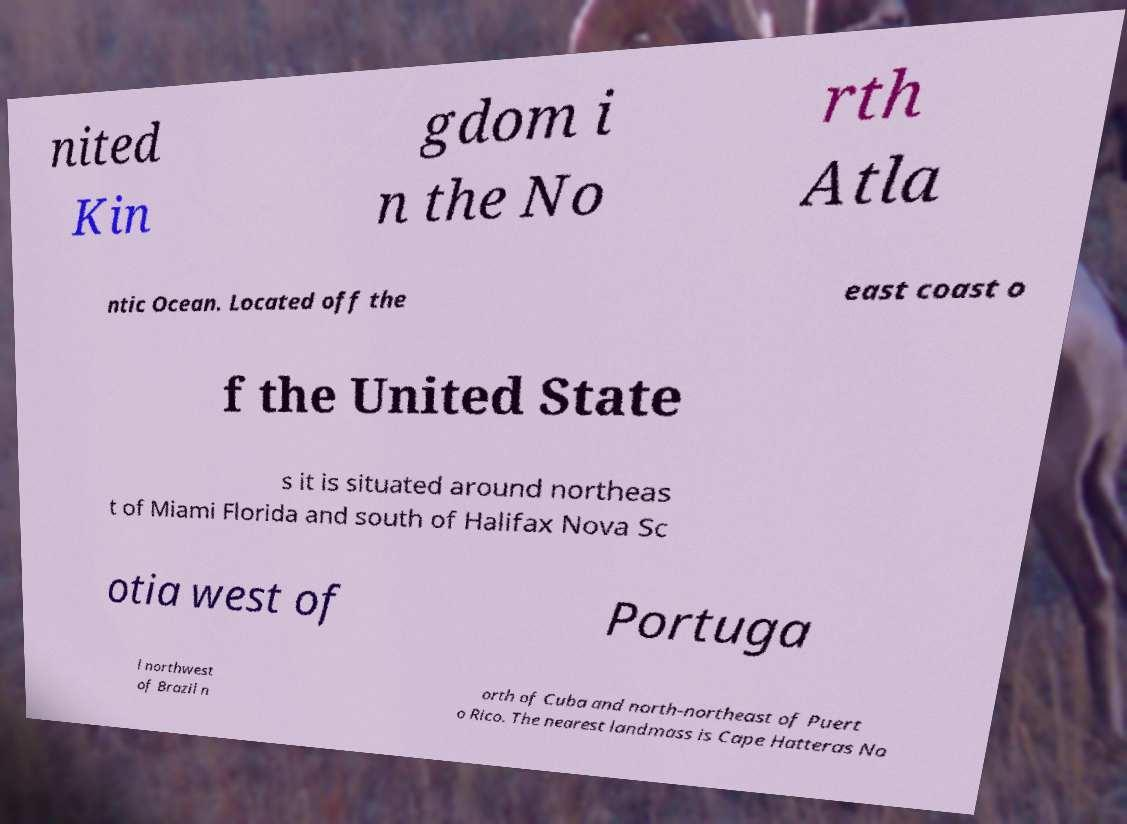Could you assist in decoding the text presented in this image and type it out clearly? nited Kin gdom i n the No rth Atla ntic Ocean. Located off the east coast o f the United State s it is situated around northeas t of Miami Florida and south of Halifax Nova Sc otia west of Portuga l northwest of Brazil n orth of Cuba and north-northeast of Puert o Rico. The nearest landmass is Cape Hatteras No 